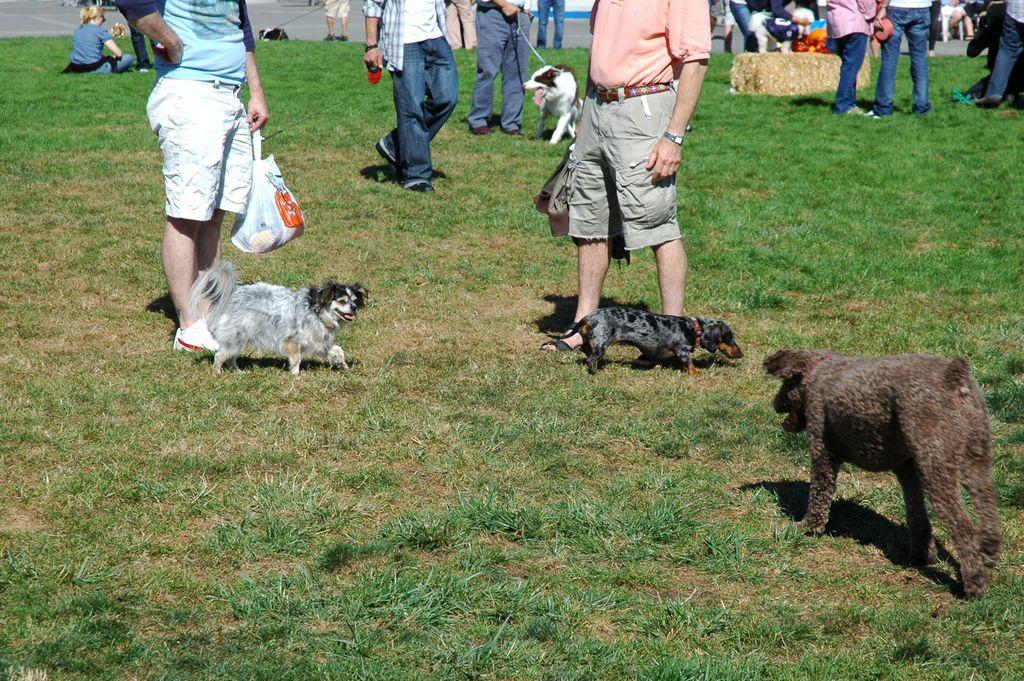What are the persons in the image doing? The persons in the image are standing on the ground. Can you describe the animals visible in the image? Unfortunately, the facts provided do not specify the type of animals present in the image. What type of leather is being used to make the toad's shoes in the image? There is no toad or shoes present in the image, so it is not possible to determine what type of leather might be used. 